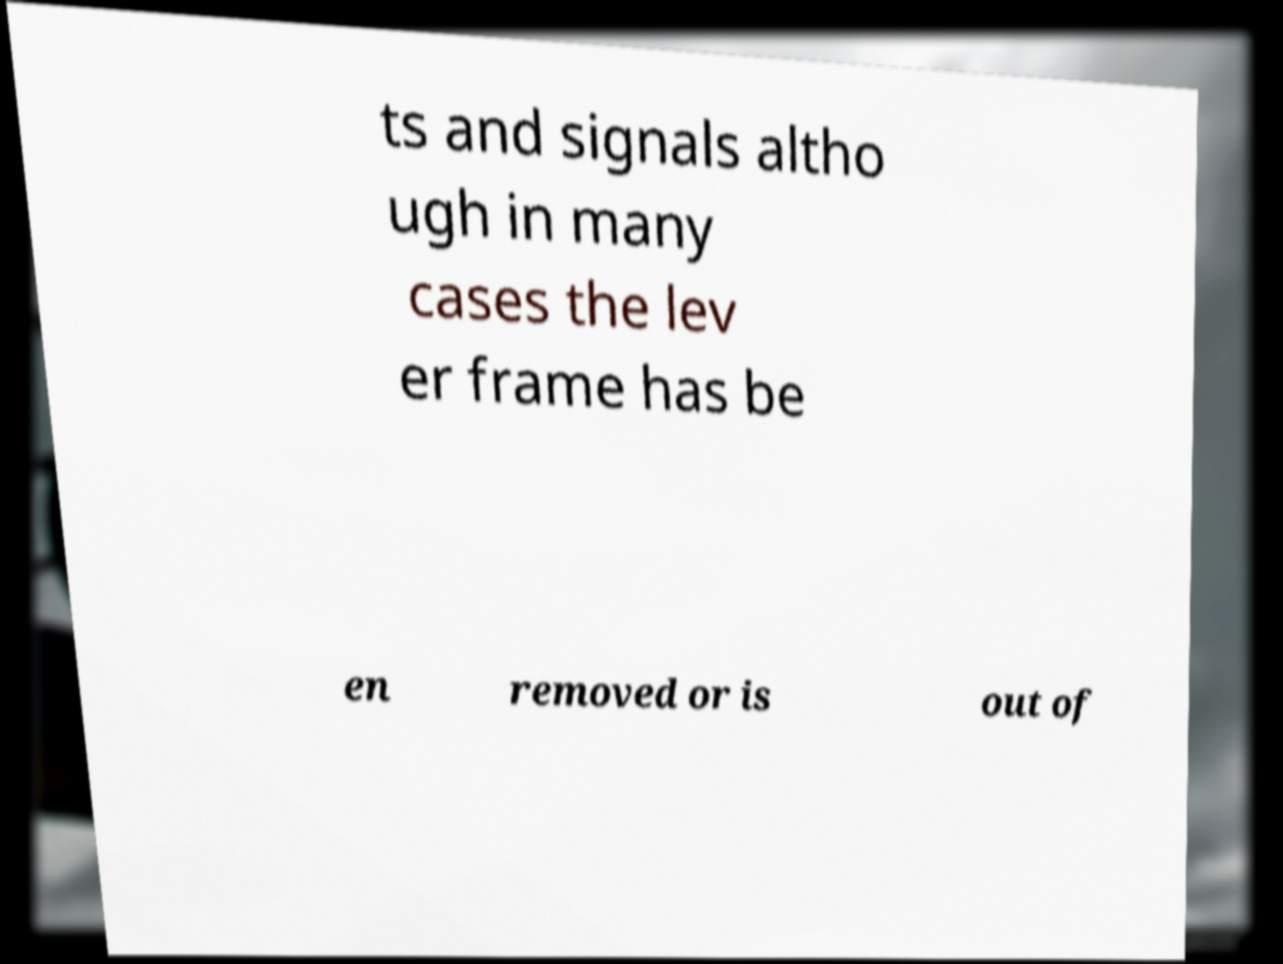There's text embedded in this image that I need extracted. Can you transcribe it verbatim? ts and signals altho ugh in many cases the lev er frame has be en removed or is out of 